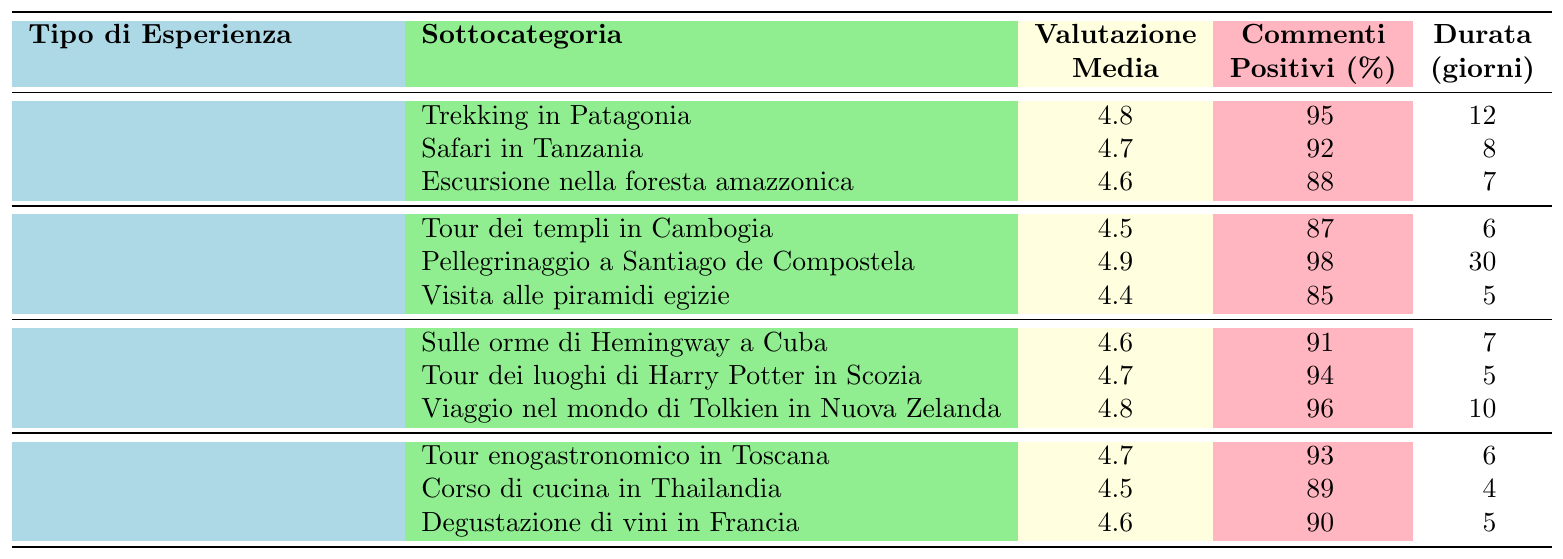Qual è l'esperienza di viaggio con la valutazione media più alta? Dalla tabella, la valutazione media più alta è 4.9, che corrisponde al "Pellegrinaggio a Santiago de Compostela".
Answer: Pellegrinaggio a Santiago de Compostela Qual è la durata media del "Trekking in Patagonia"? La durata media per il "Trekking in Patagonia" è di 12 giorni, come indicato nella tabella.
Answer: 12 giorni Quali esperienze di viaggio hanno una valutazione media superiore a 4.7? Controllando la tabella, le esperienze con valutazione media superiore a 4.7 sono il "Pellegrinaggio a Santiago de Compostela" (4.9), "Viaggio nel mondo di Tolkien in Nuova Zelanda" (4.8), e "Trekking in Patagonia" (4.8).
Answer: Pellegrinaggio a Santiago de Compostela, Viaggio nel mondo di Tolkien in Nuova Zelanda, Trekking in Patagonia Qual è la percentuale di commenti positivi per il "Corso di cucina in Thailandia"? La percentuale di commenti positivi per il "Corso di cucina in Thailandia" è 89%, come riportato nella tabella.
Answer: 89% Quante esperienze di viaggio hanno una durata media inferiore ai 6 giorni? Esaminando i dati, ci sono 4 esperienze: "Tour dei templi in Cambogia" (6 giorni), "Visita alle piramidi egizie" (5 giorni), "Corso di cucina in Thailandia" (4 giorni) e "Degustazione di vini in Francia" (5 giorni). Due di queste sono inferiori a 6 giorni: "Visita alle piramidi egizie", "Corso di cucina in Thailandia" e "Degustazione di vini in Francia".
Answer: 3 esperienze Qual è l'esperienza di viaggio con il maggior numero di commenti positivi? Dalla tabella, l'esperienza con il maggior numero di commenti positivi è il "Pellegrinaggio a Santiago de Compostela" con il 98% di commenti positivi.
Answer: Pellegrinaggio a Santiago de Compostela Qual è la differenza nella valutazione media tra l'esperienza "Safari in Tanzania" e "Tour dei templi in Cambogia"? "Safari in Tanzania" ha una valutazione di 4.7 mentre "Tour dei templi in Cambogia" ha una valutazione di 4.5. La differenza è 4.7 - 4.5 = 0.2.
Answer: 0.2 Qual è l'esperienza gastronomica con la valutazione media più bassa? Controllando la tabella, l'esperienza gastronomica con la valutazione media più bassa è il "Corso di cucina in Thailandia" con un valutazione di 4.5.
Answer: Corso di cucina in Thailandia Quanti giorni medi sono richiesti per "Tour dei luoghi di Harry Potter in Scozia"? La durata media per il "Tour dei luoghi di Harry Potter in Scozia" è di 5 giorni, come indicato nella tabella.
Answer: 5 giorni C'è un'esperienza di viaggio nella categoria "Viaggi letterari" con percentuali di commenti positivi inferiori al 90%? Sì, l'esperienza "Sulle orme di Hemingway a Cuba" ha il 91% di commenti positivi, mentre "Tour dei luoghi di Harry Potter in Scozia" ha il 94%. Non ce ne sono sotto il 90%.
Answer: No Qual è la valutazione media delle "Avventure nella natura"? La media delle valutazioni delle tre esperienze in questa categoria è (4.8 + 4.7 + 4.6) / 3 = 4.7.
Answer: 4.7 